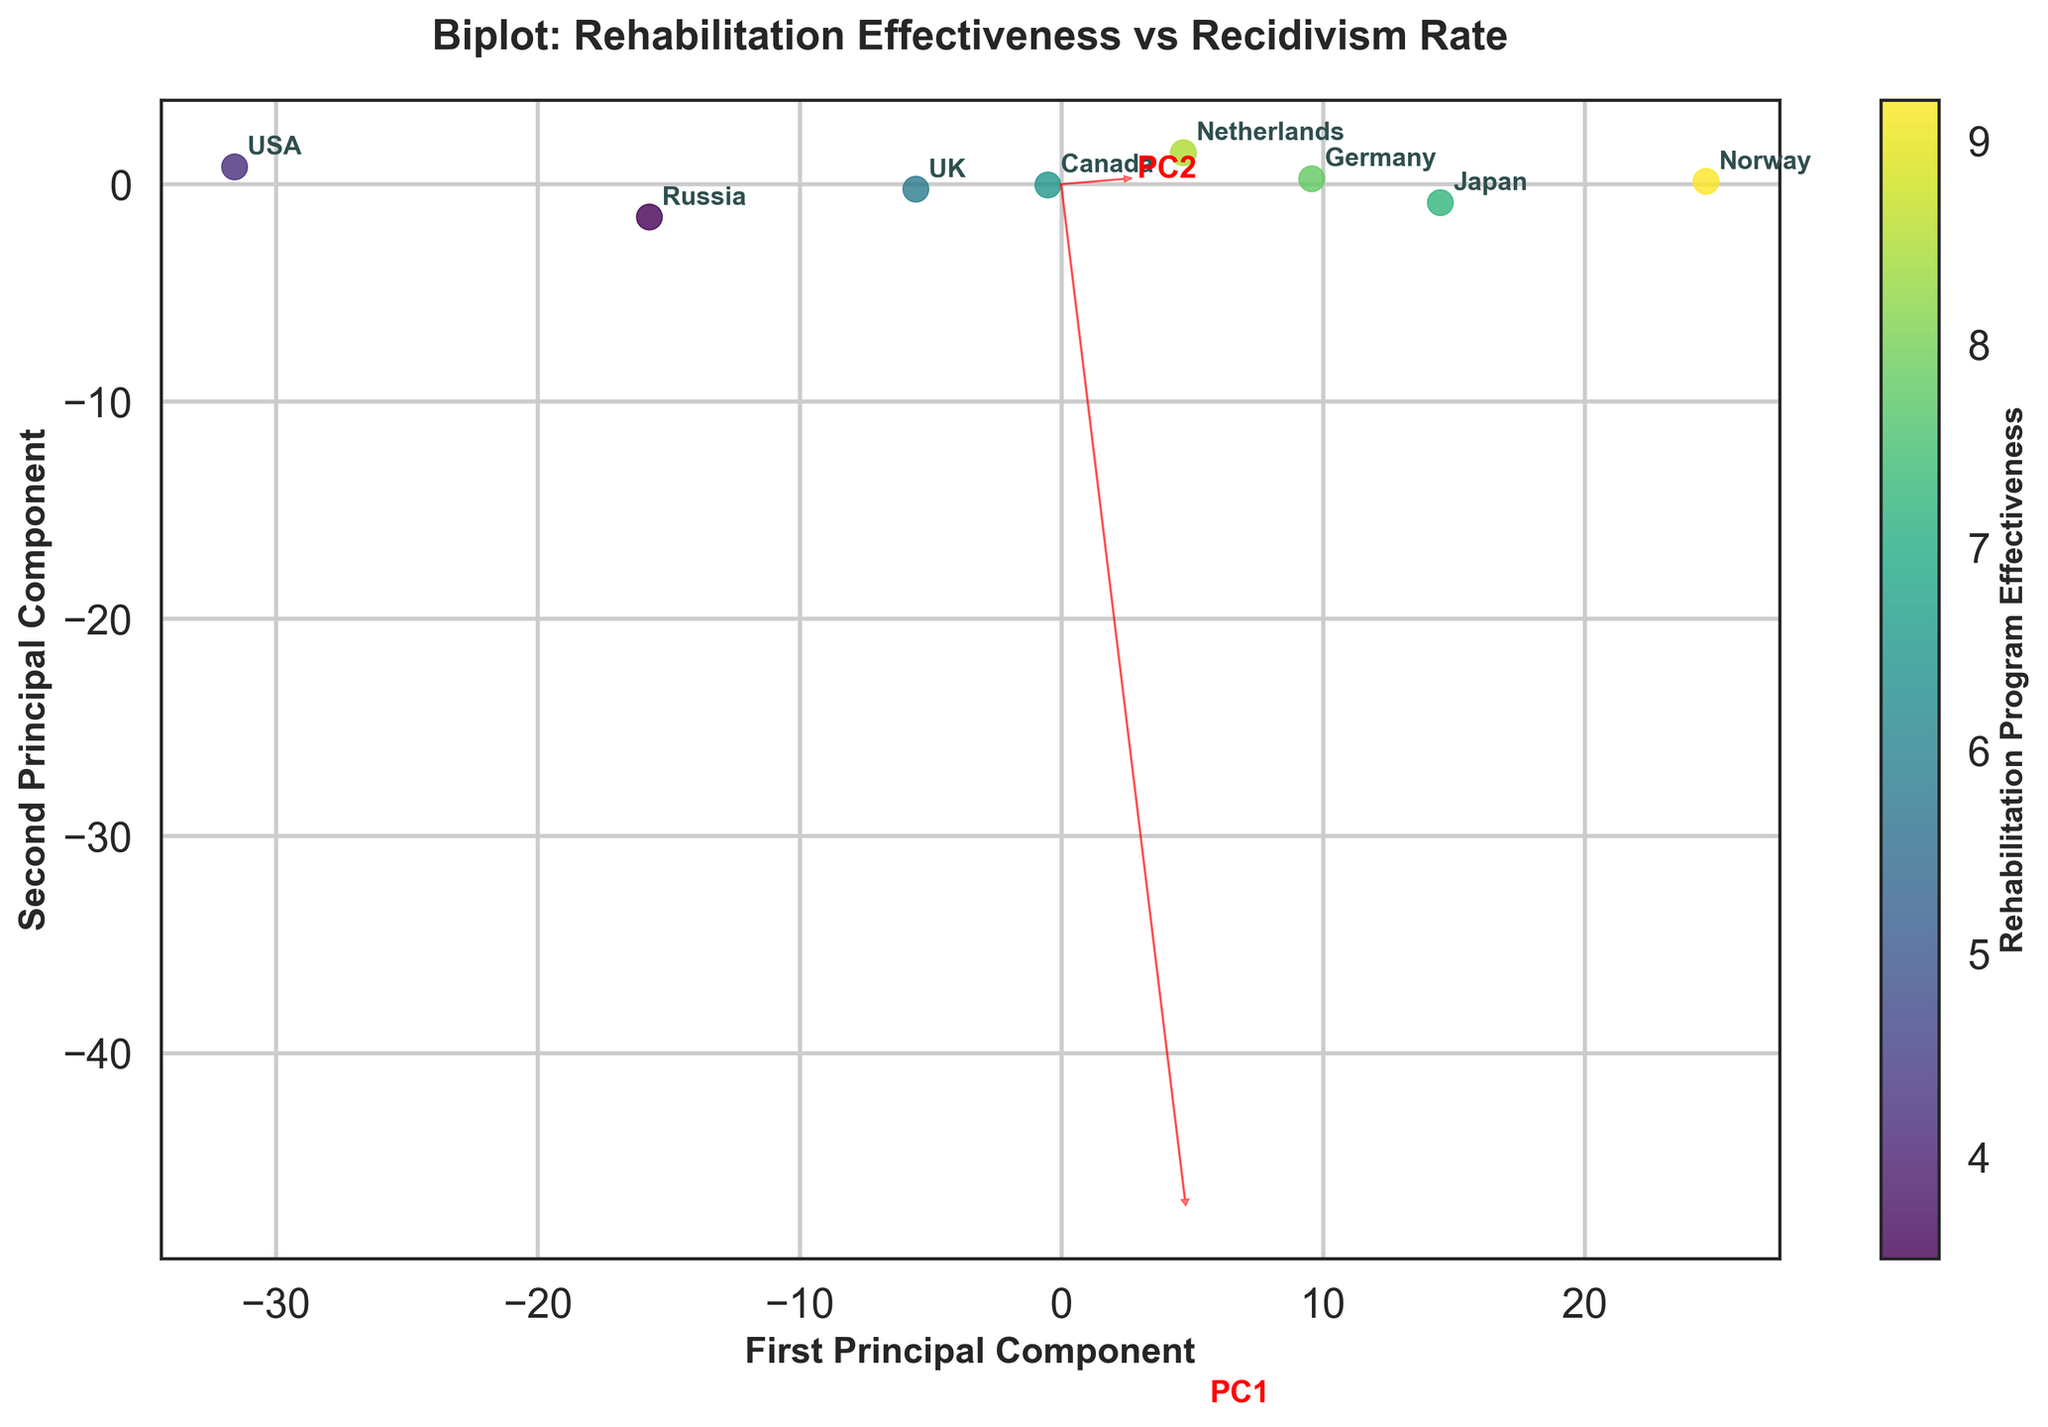What is the title of the figure? The title of the figure is typically at the top of the plot and written in large font. In this case, the title reads "Biplot: Rehabilitation Effectiveness vs Recidivism Rate".
Answer: Biplot: Rehabilitation Effectiveness vs Recidivism Rate Which axis represents the second principal component? The y-axis label details which component is being represented. Here, the y-axis is labeled "Second Principal Component".
Answer: The y-axis How many different prison systems are compared in the figure? We can count the number of data points labeled in the plot. Each point represents a different prison system. There are eight prison systems indicated.
Answer: 8 Which prison system has the highest rehabilitation program effectiveness? By looking at the color gradient from the color bar which represents rehabilitation program effectiveness, the point with a lighter color and labeled "Norway" is the highest.
Answer: Norway What does the colorbar represent? The colorbar next to the plot usually indicates what is being shown with the color gradient. Here, it is labeled 'Rehabilitation Program Effectiveness'.
Answer: Rehabilitation Program Effectiveness Which prison system has the highest recidivism rate? The recidivism rate is mapped on the x-axis as the principal component with high rehabilitation program effectiveness. The point labeled "USA" is the farthest to the right and has the highest recidivism rate.
Answer: USA Compare the recidivism rates between Norway and the USA. Norway and the USA are at opposite ends of the x-axis. Norway has a significantly lower recidivism rate compared to the USA, which is farthest right on the plot.
Answer: Norway < USA Which principal component (PC) is most correlated with rehabilitation program effectiveness? The first principal component (PC1) is represented on the x-axis and closely associated with recidivism rate. Rehabilitation program effectiveness is more visual with color, correlating mostly with the principal component on the x-axis.
Answer: PC1 Explain the significance of the arrows in the biplot. The arrows represent directions of maximum variance for the principal components. They show the extent and directions of eigenvalues, indicating which PCs account for variance in rehabilitation effectiveness and recidivism rates.
Answer: They show principal component directions Which country is closest to the average point of all countries in terms of rehabilitation effectiveness and recidivism rate? The average point of all countries would be at the origin after centering. By visual inspection, Germany seems closest to this point in the plot.
Answer: Germany 